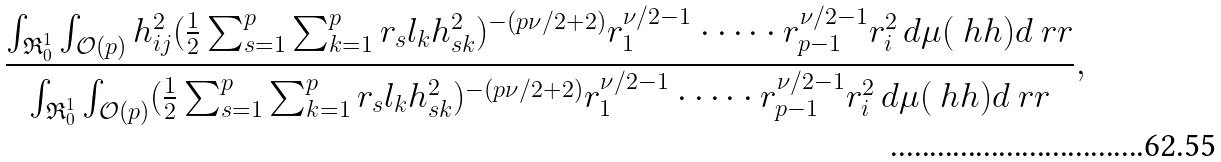Convert formula to latex. <formula><loc_0><loc_0><loc_500><loc_500>\frac { \int _ { \mathfrak { R } _ { 0 } ^ { 1 } } \int _ { \mathcal { O } ( p ) } h _ { i j } ^ { 2 } ( \frac { 1 } { 2 } \sum _ { s = 1 } ^ { p } \sum _ { k = 1 } ^ { p } r _ { s } l _ { k } h _ { s k } ^ { 2 } ) ^ { - ( p \nu / 2 + 2 ) } r _ { 1 } ^ { \nu / 2 - 1 } \cdot \dots \cdot r _ { p - 1 } ^ { \nu / 2 - 1 } r _ { i } ^ { 2 } \, d \mu ( \ h h ) d \ r r } { \int _ { \mathfrak { R } _ { 0 } ^ { 1 } } \int _ { \mathcal { O } ( p ) } ( \frac { 1 } { 2 } \sum _ { s = 1 } ^ { p } \sum _ { k = 1 } ^ { p } r _ { s } l _ { k } h _ { s k } ^ { 2 } ) ^ { - ( p \nu / 2 + 2 ) } r _ { 1 } ^ { \nu / 2 - 1 } \cdot \dots \cdot r _ { p - 1 } ^ { \nu / 2 - 1 } r _ { i } ^ { 2 } \, d \mu ( \ h h ) d \ r r } ,</formula> 